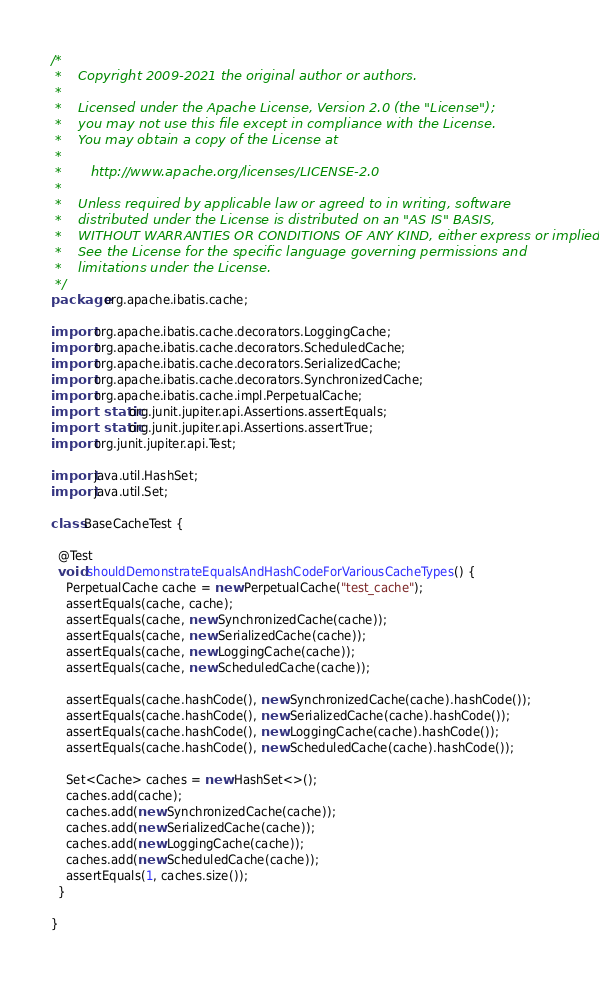Convert code to text. <code><loc_0><loc_0><loc_500><loc_500><_Java_>/*
 *    Copyright 2009-2021 the original author or authors.
 *
 *    Licensed under the Apache License, Version 2.0 (the "License");
 *    you may not use this file except in compliance with the License.
 *    You may obtain a copy of the License at
 *
 *       http://www.apache.org/licenses/LICENSE-2.0
 *
 *    Unless required by applicable law or agreed to in writing, software
 *    distributed under the License is distributed on an "AS IS" BASIS,
 *    WITHOUT WARRANTIES OR CONDITIONS OF ANY KIND, either express or implied.
 *    See the License for the specific language governing permissions and
 *    limitations under the License.
 */
package org.apache.ibatis.cache;

import org.apache.ibatis.cache.decorators.LoggingCache;
import org.apache.ibatis.cache.decorators.ScheduledCache;
import org.apache.ibatis.cache.decorators.SerializedCache;
import org.apache.ibatis.cache.decorators.SynchronizedCache;
import org.apache.ibatis.cache.impl.PerpetualCache;
import static org.junit.jupiter.api.Assertions.assertEquals;
import static org.junit.jupiter.api.Assertions.assertTrue;
import org.junit.jupiter.api.Test;

import java.util.HashSet;
import java.util.Set;

class BaseCacheTest {

  @Test
  void shouldDemonstrateEqualsAndHashCodeForVariousCacheTypes() {
    PerpetualCache cache = new PerpetualCache("test_cache");
    assertEquals(cache, cache);
    assertEquals(cache, new SynchronizedCache(cache));
    assertEquals(cache, new SerializedCache(cache));
    assertEquals(cache, new LoggingCache(cache));
    assertEquals(cache, new ScheduledCache(cache));

    assertEquals(cache.hashCode(), new SynchronizedCache(cache).hashCode());
    assertEquals(cache.hashCode(), new SerializedCache(cache).hashCode());
    assertEquals(cache.hashCode(), new LoggingCache(cache).hashCode());
    assertEquals(cache.hashCode(), new ScheduledCache(cache).hashCode());

    Set<Cache> caches = new HashSet<>();
    caches.add(cache);
    caches.add(new SynchronizedCache(cache));
    caches.add(new SerializedCache(cache));
    caches.add(new LoggingCache(cache));
    caches.add(new ScheduledCache(cache));
    assertEquals(1, caches.size());
  }

}
</code> 